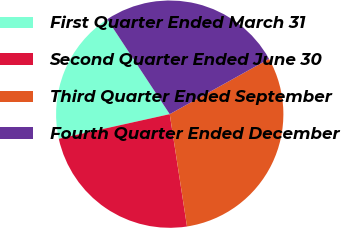<chart> <loc_0><loc_0><loc_500><loc_500><pie_chart><fcel>First Quarter Ended March 31<fcel>Second Quarter Ended June 30<fcel>Third Quarter Ended September<fcel>Fourth Quarter Ended December<nl><fcel>19.21%<fcel>23.95%<fcel>30.65%<fcel>26.19%<nl></chart> 